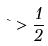<formula> <loc_0><loc_0><loc_500><loc_500>\theta > \frac { 1 } { 2 }</formula> 